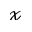Convert formula to latex. <formula><loc_0><loc_0><loc_500><loc_500>\mathcal { x }</formula> 